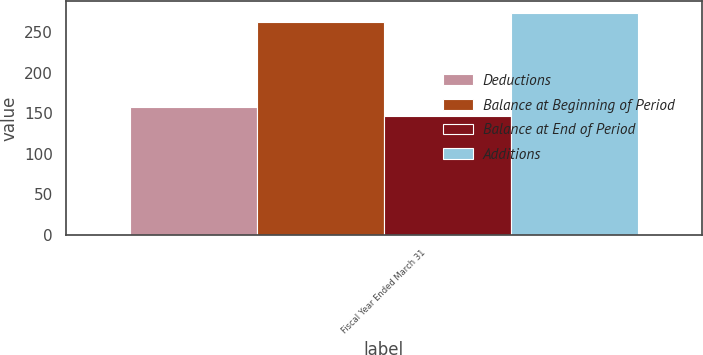Convert chart. <chart><loc_0><loc_0><loc_500><loc_500><stacked_bar_chart><ecel><fcel>Fiscal Year Ended March 31<nl><fcel>Deductions<fcel>158<nl><fcel>Balance at Beginning of Period<fcel>262<nl><fcel>Balance at End of Period<fcel>146<nl><fcel>Additions<fcel>274<nl></chart> 